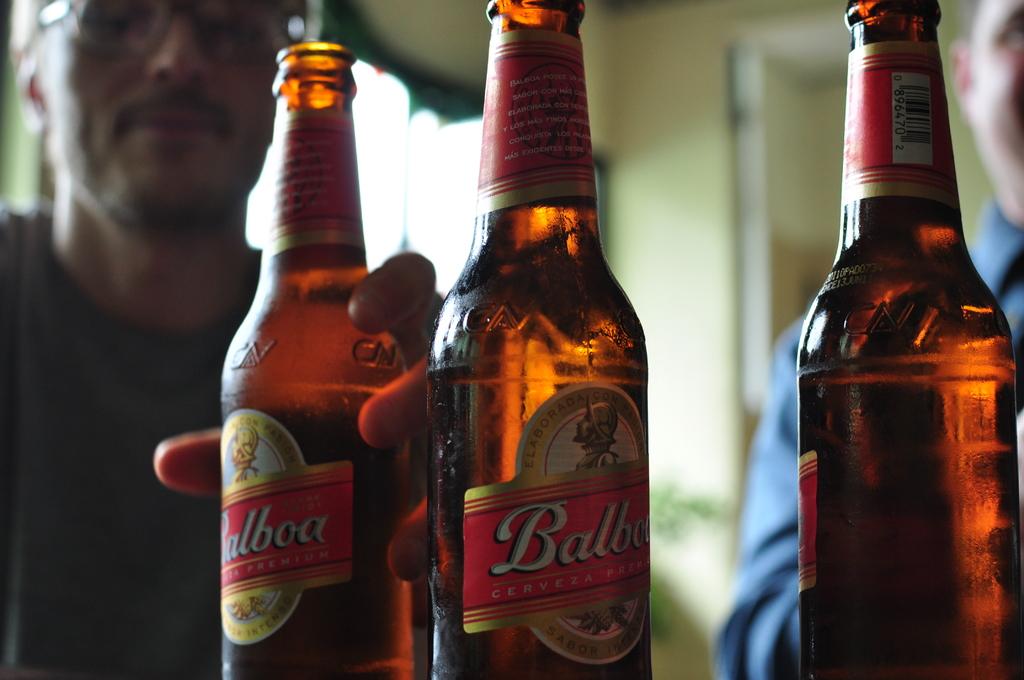What beer brand is that?
Your answer should be compact. Balboa. 